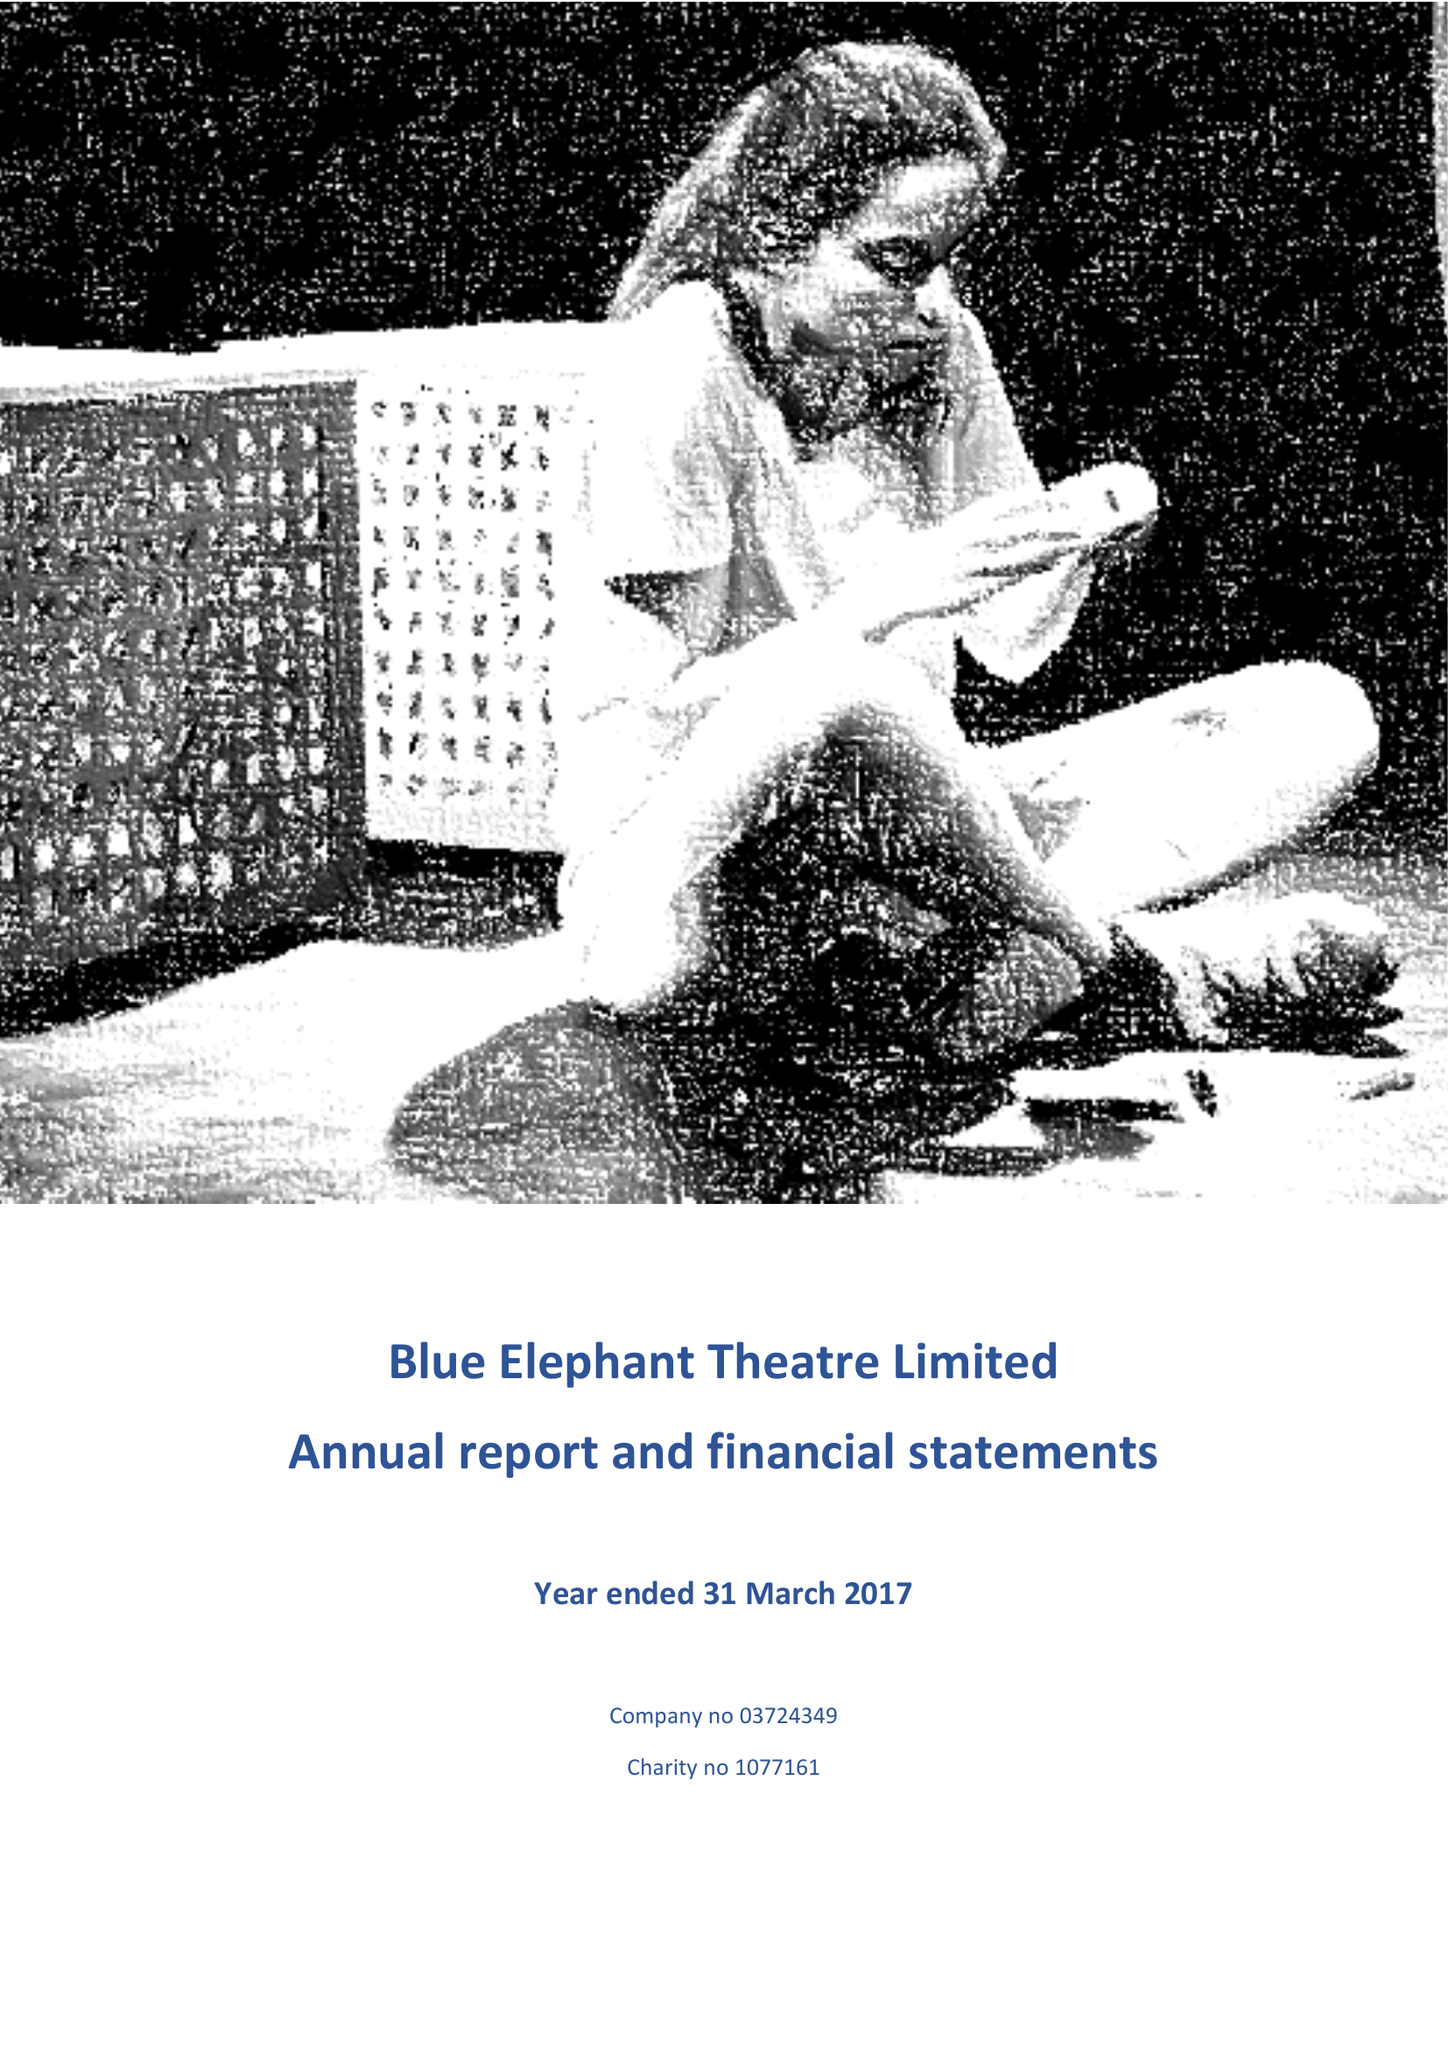What is the value for the charity_name?
Answer the question using a single word or phrase. Blue Elephant Theatre Ltd. 